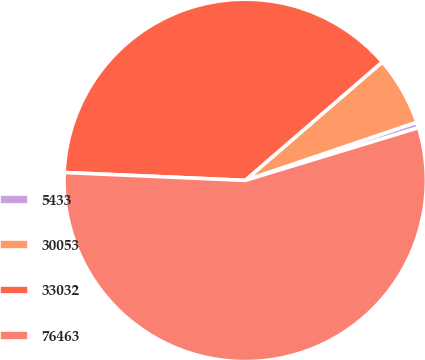Convert chart to OTSL. <chart><loc_0><loc_0><loc_500><loc_500><pie_chart><fcel>5433<fcel>30053<fcel>33032<fcel>76463<nl><fcel>0.51%<fcel>6.13%<fcel>37.97%<fcel>55.39%<nl></chart> 